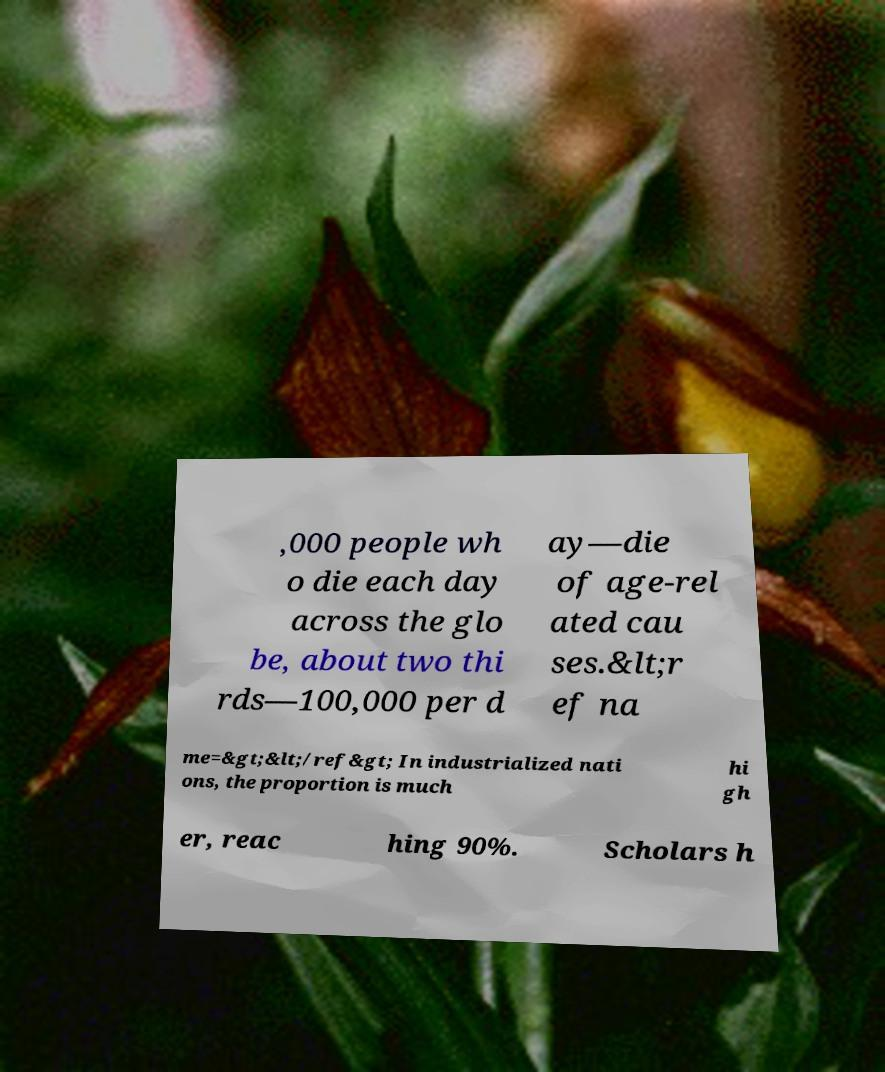What messages or text are displayed in this image? I need them in a readable, typed format. ,000 people wh o die each day across the glo be, about two thi rds—100,000 per d ay—die of age-rel ated cau ses.&lt;r ef na me=&gt;&lt;/ref&gt; In industrialized nati ons, the proportion is much hi gh er, reac hing 90%. Scholars h 